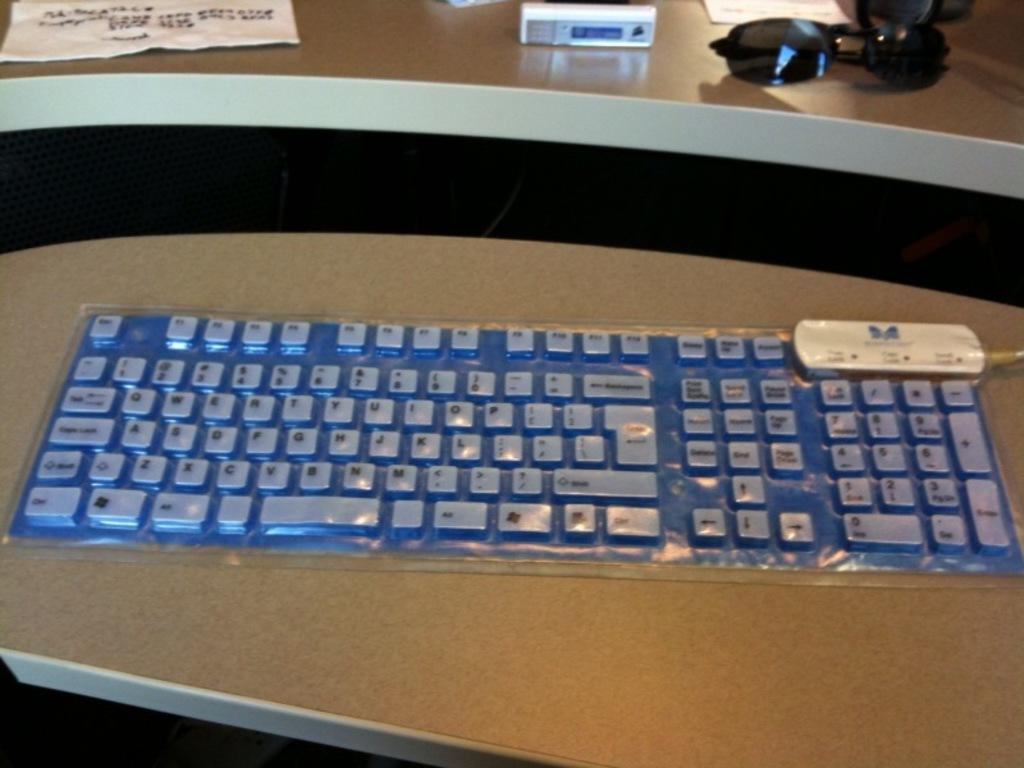What is on the table in the image? There is a keyboard on a table in the image. What else can be seen on another table in the image? There is a paper and a device on the second table in the image. What additional item is on the second table? There are black color goggles on the second table in the image. How many lizards are crawling on the keyboard in the image? There are no lizards present in the image; the keyboard is the only item on the table. 